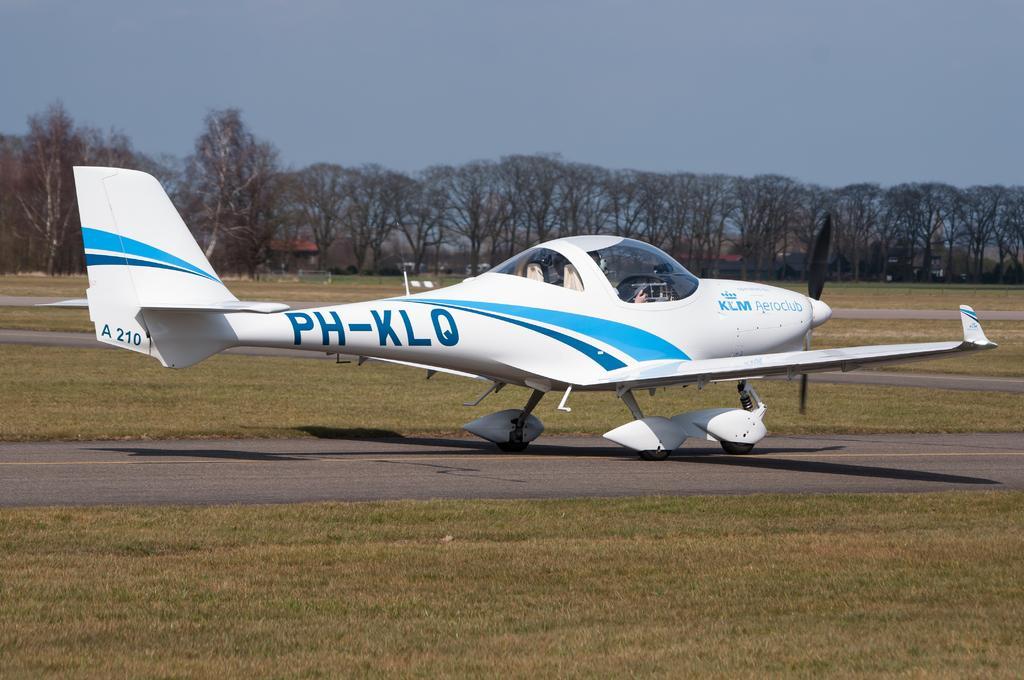How would you summarize this image in a sentence or two? In the center we can see a white color aircraft seems to be parked on the ground and we can see the grass. In the background we can see the sky, trees and some other objects. 